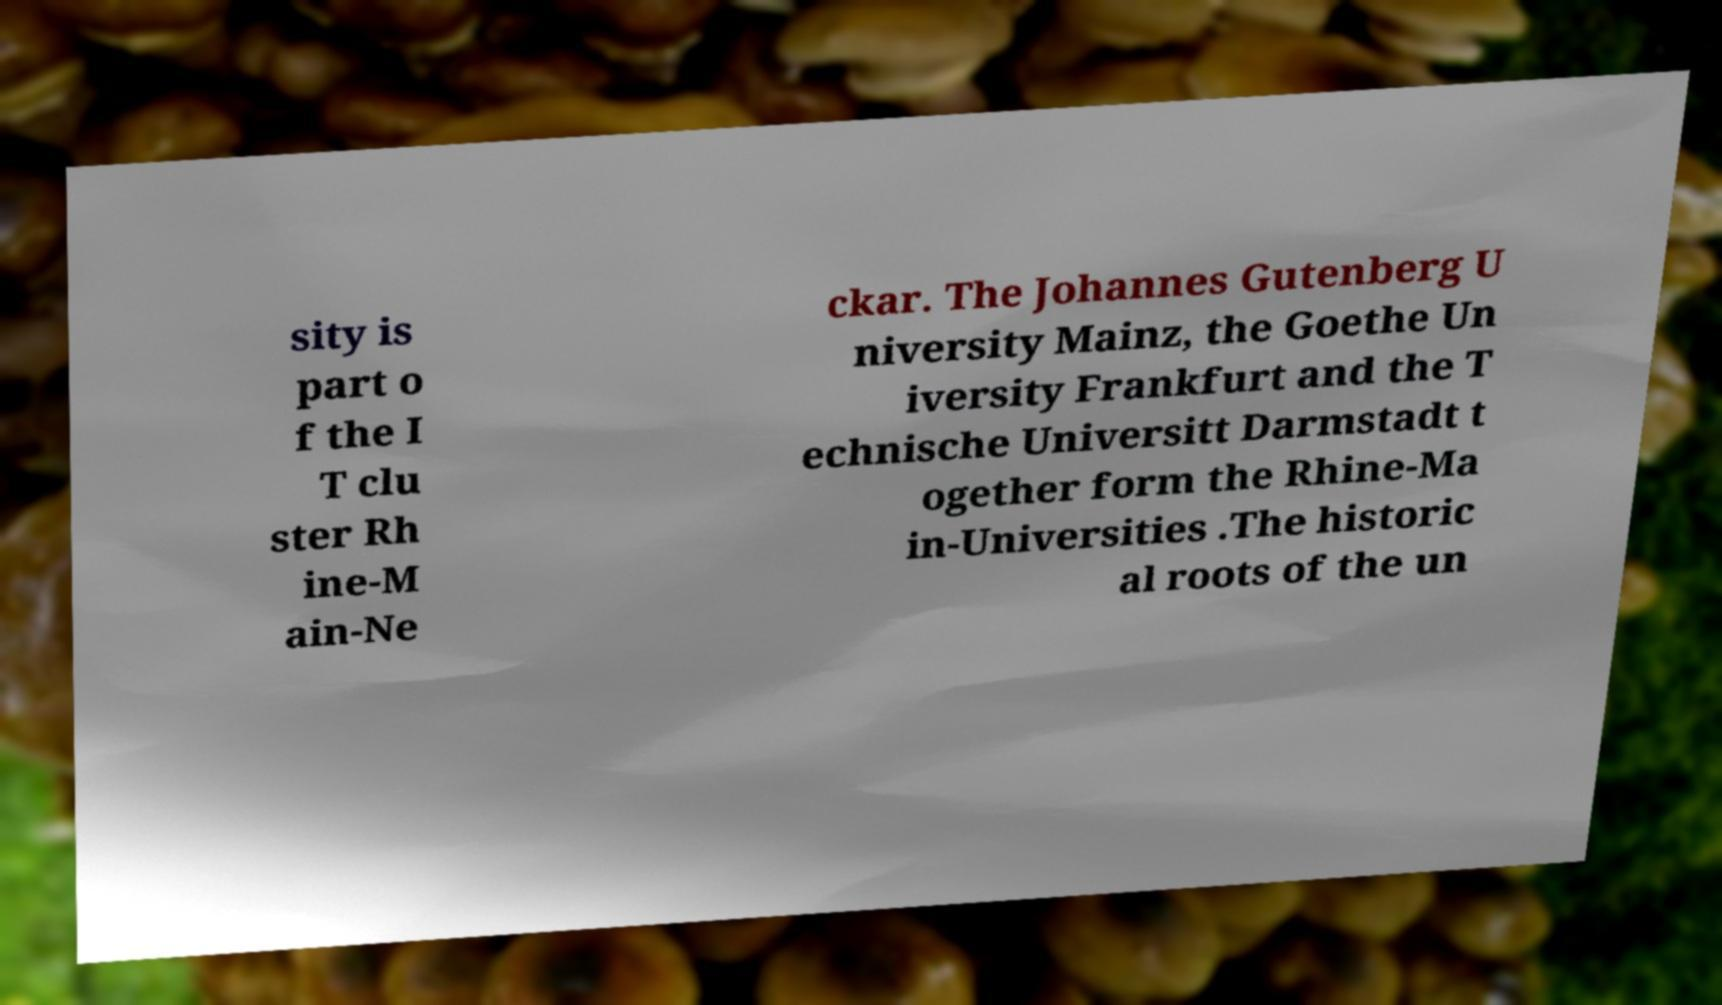Could you assist in decoding the text presented in this image and type it out clearly? sity is part o f the I T clu ster Rh ine-M ain-Ne ckar. The Johannes Gutenberg U niversity Mainz, the Goethe Un iversity Frankfurt and the T echnische Universitt Darmstadt t ogether form the Rhine-Ma in-Universities .The historic al roots of the un 